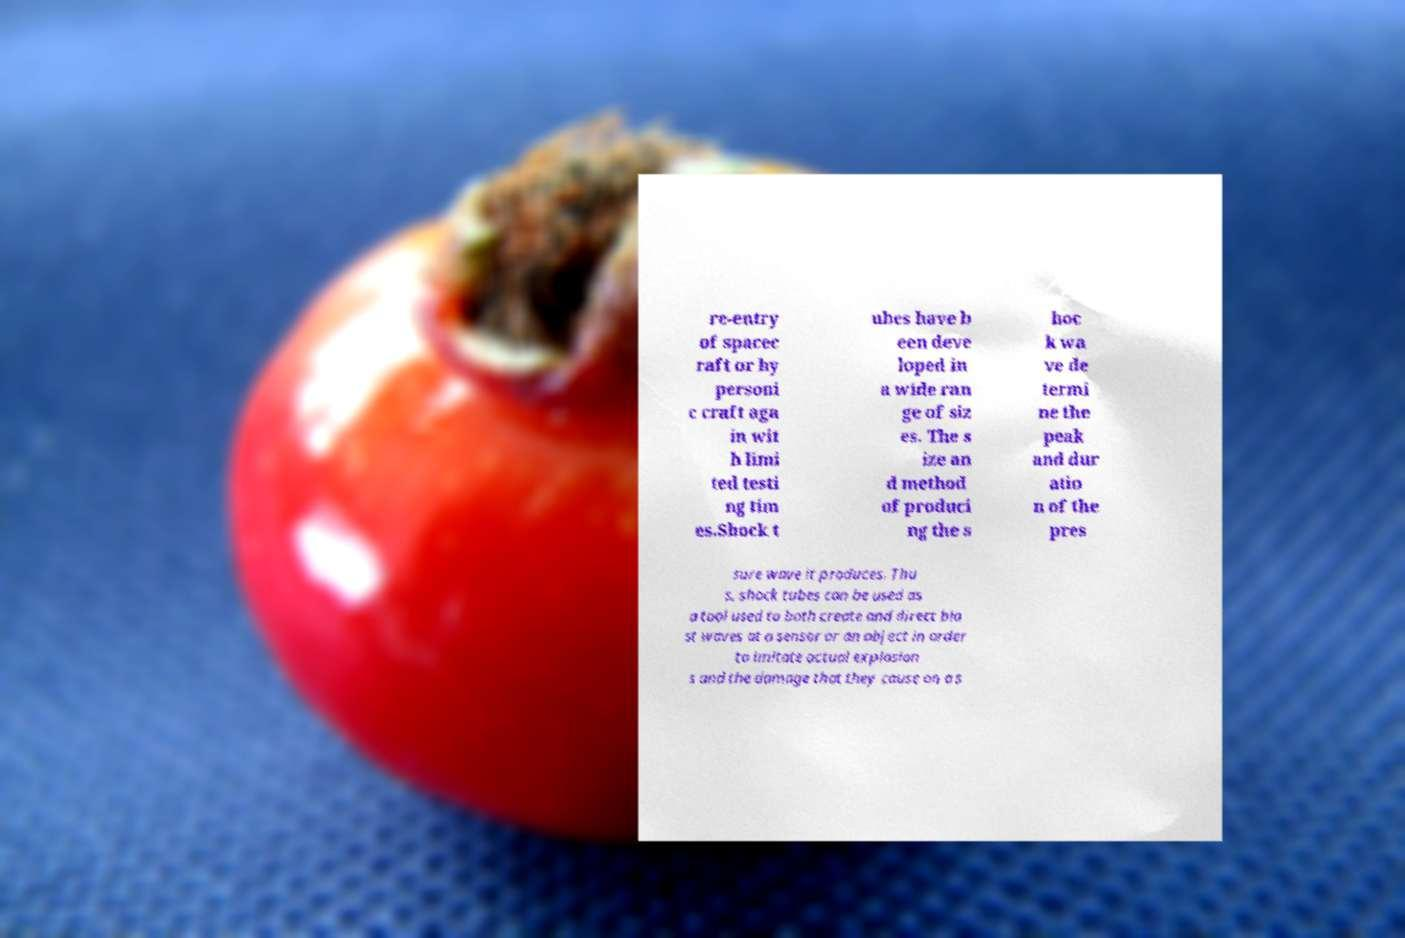Please read and relay the text visible in this image. What does it say? re-entry of spacec raft or hy personi c craft aga in wit h limi ted testi ng tim es.Shock t ubes have b een deve loped in a wide ran ge of siz es. The s ize an d method of produci ng the s hoc k wa ve de termi ne the peak and dur atio n of the pres sure wave it produces. Thu s, shock tubes can be used as a tool used to both create and direct bla st waves at a sensor or an object in order to imitate actual explosion s and the damage that they cause on a s 